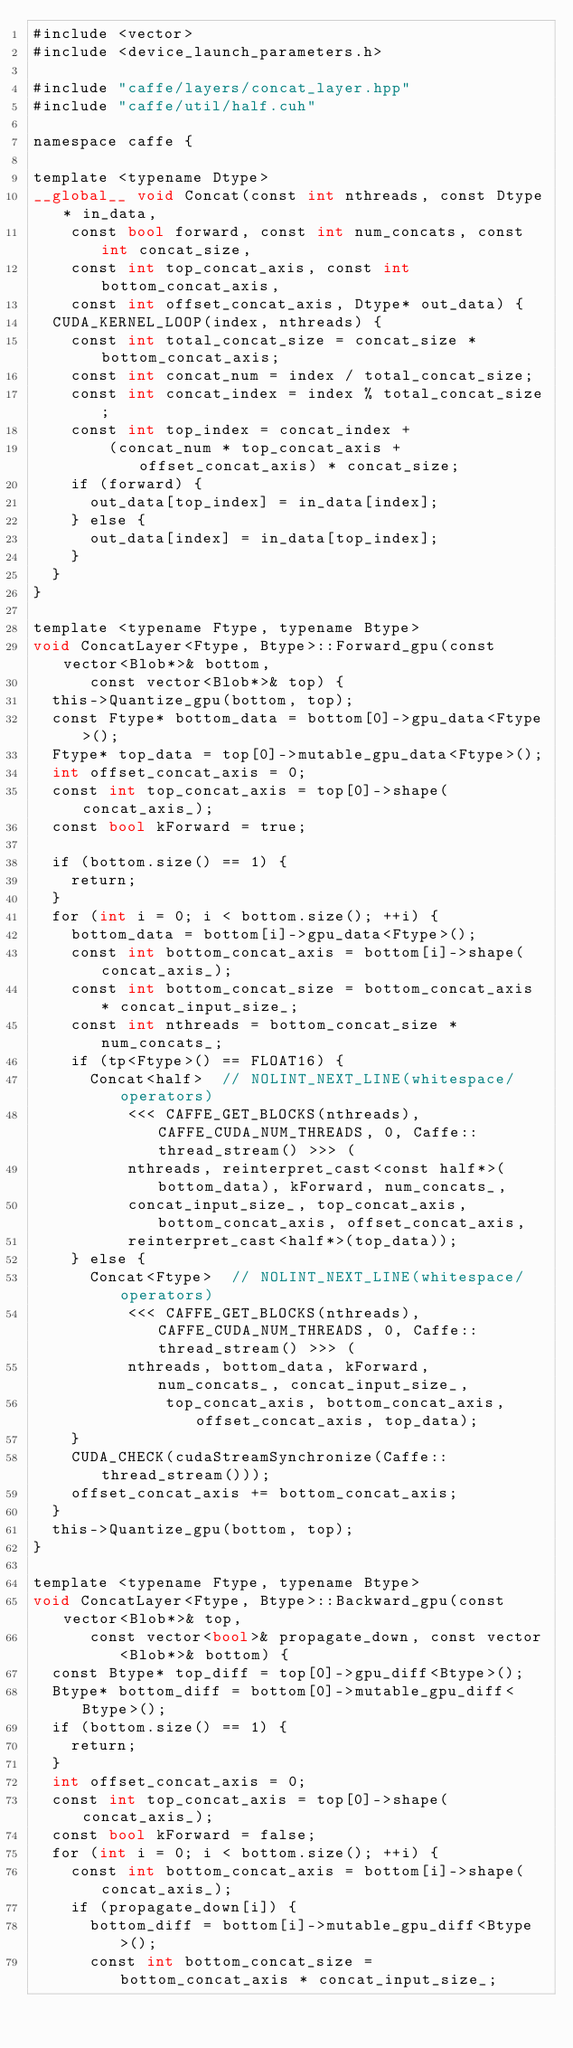Convert code to text. <code><loc_0><loc_0><loc_500><loc_500><_Cuda_>#include <vector>
#include <device_launch_parameters.h>

#include "caffe/layers/concat_layer.hpp"
#include "caffe/util/half.cuh"

namespace caffe {

template <typename Dtype>
__global__ void Concat(const int nthreads, const Dtype* in_data,
    const bool forward, const int num_concats, const int concat_size,
    const int top_concat_axis, const int bottom_concat_axis,
    const int offset_concat_axis, Dtype* out_data) {
  CUDA_KERNEL_LOOP(index, nthreads) {
    const int total_concat_size = concat_size * bottom_concat_axis;
    const int concat_num = index / total_concat_size;
    const int concat_index = index % total_concat_size;
    const int top_index = concat_index +
        (concat_num * top_concat_axis + offset_concat_axis) * concat_size;
    if (forward) {
      out_data[top_index] = in_data[index];
    } else {
      out_data[index] = in_data[top_index];
    }
  }
}

template <typename Ftype, typename Btype>
void ConcatLayer<Ftype, Btype>::Forward_gpu(const vector<Blob*>& bottom,
      const vector<Blob*>& top) {
  this->Quantize_gpu(bottom, top);
  const Ftype* bottom_data = bottom[0]->gpu_data<Ftype>();
  Ftype* top_data = top[0]->mutable_gpu_data<Ftype>();
  int offset_concat_axis = 0;
  const int top_concat_axis = top[0]->shape(concat_axis_);
  const bool kForward = true;

  if (bottom.size() == 1) {
    return;
  }
  for (int i = 0; i < bottom.size(); ++i) {
    bottom_data = bottom[i]->gpu_data<Ftype>();
    const int bottom_concat_axis = bottom[i]->shape(concat_axis_);
    const int bottom_concat_size = bottom_concat_axis * concat_input_size_;
    const int nthreads = bottom_concat_size * num_concats_;
    if (tp<Ftype>() == FLOAT16) {
      Concat<half>  // NOLINT_NEXT_LINE(whitespace/operators)
          <<< CAFFE_GET_BLOCKS(nthreads), CAFFE_CUDA_NUM_THREADS, 0, Caffe::thread_stream() >>> (
          nthreads, reinterpret_cast<const half*>(bottom_data), kForward, num_concats_,
          concat_input_size_, top_concat_axis, bottom_concat_axis, offset_concat_axis,
          reinterpret_cast<half*>(top_data));
    } else {
      Concat<Ftype>  // NOLINT_NEXT_LINE(whitespace/operators)
          <<< CAFFE_GET_BLOCKS(nthreads), CAFFE_CUDA_NUM_THREADS, 0, Caffe::thread_stream() >>> (
          nthreads, bottom_data, kForward, num_concats_, concat_input_size_,
              top_concat_axis, bottom_concat_axis, offset_concat_axis, top_data);
    }
    CUDA_CHECK(cudaStreamSynchronize(Caffe::thread_stream()));
    offset_concat_axis += bottom_concat_axis;
  }
  this->Quantize_gpu(bottom, top);
}

template <typename Ftype, typename Btype>
void ConcatLayer<Ftype, Btype>::Backward_gpu(const vector<Blob*>& top,
      const vector<bool>& propagate_down, const vector<Blob*>& bottom) {
  const Btype* top_diff = top[0]->gpu_diff<Btype>();
  Btype* bottom_diff = bottom[0]->mutable_gpu_diff<Btype>();
  if (bottom.size() == 1) {
    return;
  }
  int offset_concat_axis = 0;
  const int top_concat_axis = top[0]->shape(concat_axis_);
  const bool kForward = false;
  for (int i = 0; i < bottom.size(); ++i) {
    const int bottom_concat_axis = bottom[i]->shape(concat_axis_);
    if (propagate_down[i]) {
      bottom_diff = bottom[i]->mutable_gpu_diff<Btype>();
      const int bottom_concat_size = bottom_concat_axis * concat_input_size_;</code> 